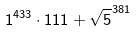<formula> <loc_0><loc_0><loc_500><loc_500>1 ^ { 4 3 3 } \cdot 1 1 1 + \sqrt { 5 } ^ { 3 8 1 }</formula> 